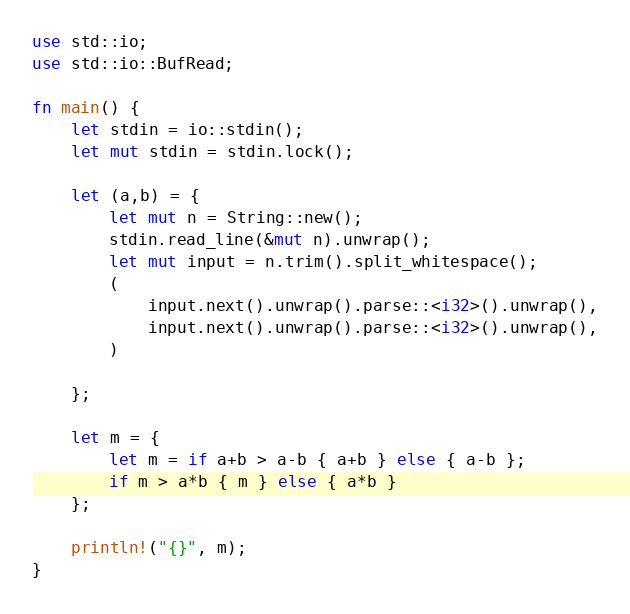Convert code to text. <code><loc_0><loc_0><loc_500><loc_500><_Rust_>use std::io;
use std::io::BufRead;

fn main() {
    let stdin = io::stdin();
    let mut stdin = stdin.lock();
    
    let (a,b) = {
        let mut n = String::new();
        stdin.read_line(&mut n).unwrap();
        let mut input = n.trim().split_whitespace();
        (
            input.next().unwrap().parse::<i32>().unwrap(),
            input.next().unwrap().parse::<i32>().unwrap(),
        )
        
    };

    let m = {
        let m = if a+b > a-b { a+b } else { a-b };
        if m > a*b { m } else { a*b }
    };

    println!("{}", m);
}
</code> 